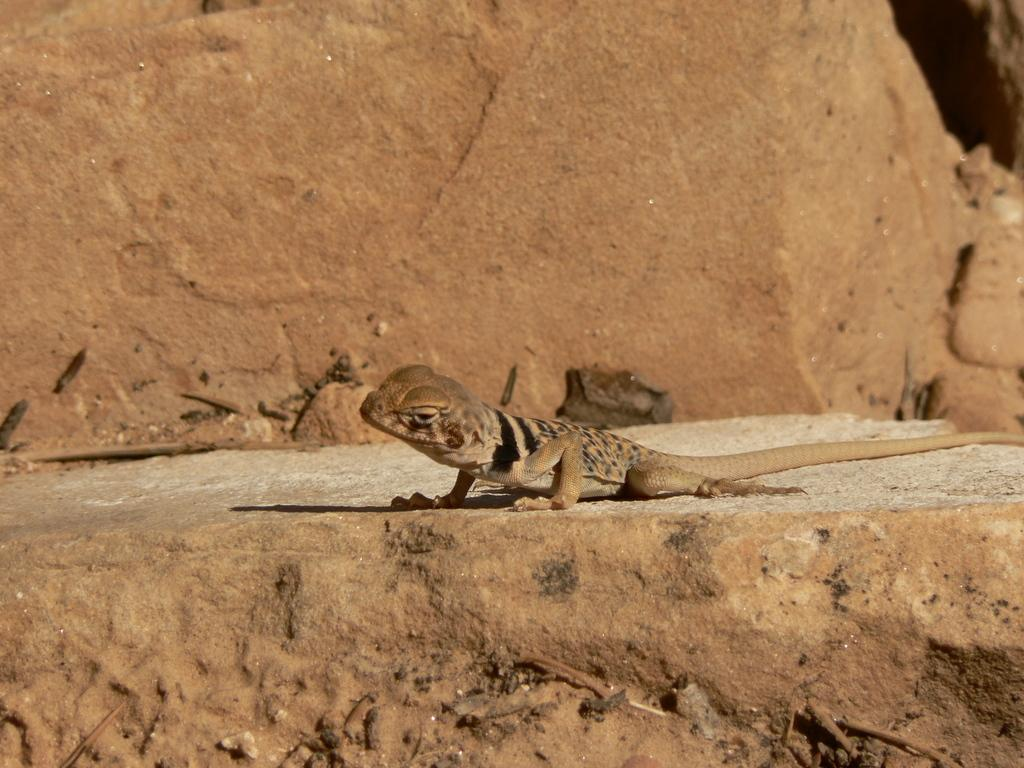What type of animal is in the image? There is a lizard in the image. Where is the lizard located? The lizard is on a rock. What type of cord is being used by the lizard in the image? There is no cord present in the image, as it features a lizard on a rock. 